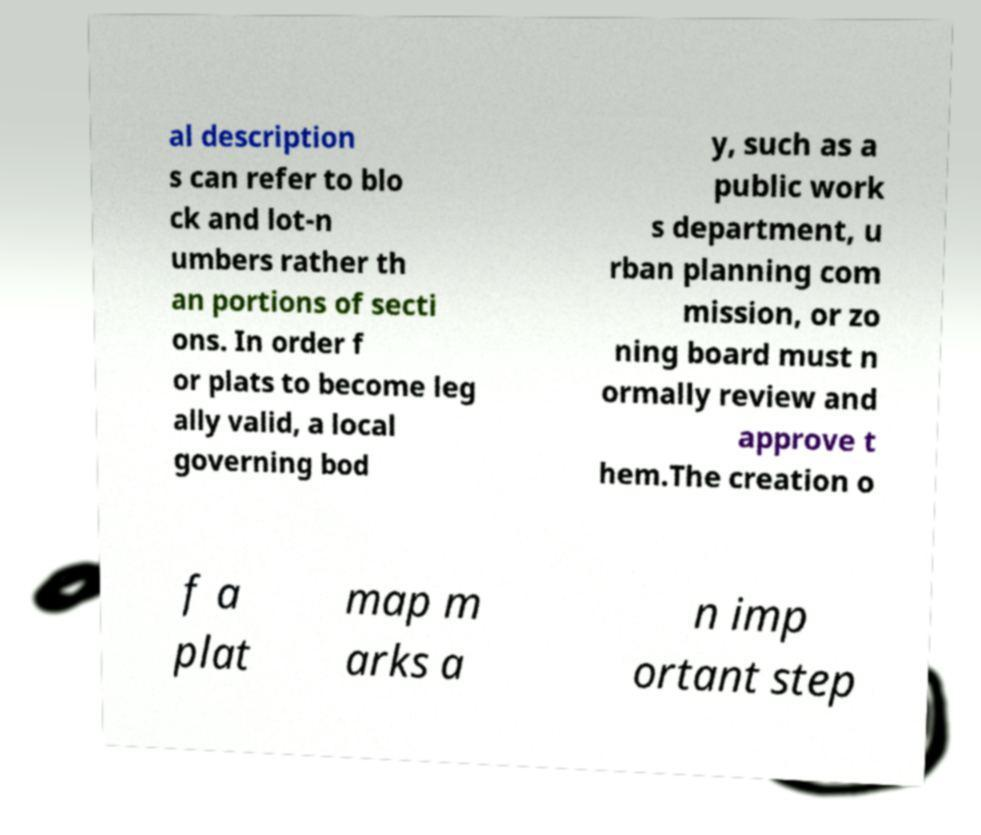I need the written content from this picture converted into text. Can you do that? al description s can refer to blo ck and lot-n umbers rather th an portions of secti ons. In order f or plats to become leg ally valid, a local governing bod y, such as a public work s department, u rban planning com mission, or zo ning board must n ormally review and approve t hem.The creation o f a plat map m arks a n imp ortant step 